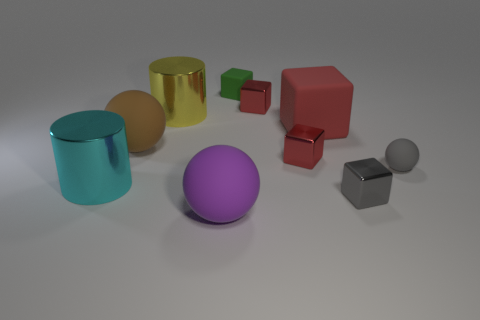Subtract all red cubes. How many were subtracted if there are1red cubes left? 2 Subtract all purple cylinders. How many red cubes are left? 3 Subtract all green cubes. How many cubes are left? 4 Subtract all gray shiny cubes. How many cubes are left? 4 Subtract all purple cubes. Subtract all purple cylinders. How many cubes are left? 5 Subtract all cylinders. How many objects are left? 8 Subtract 0 cyan blocks. How many objects are left? 10 Subtract all tiny brown rubber spheres. Subtract all big rubber spheres. How many objects are left? 8 Add 1 small gray blocks. How many small gray blocks are left? 2 Add 4 brown balls. How many brown balls exist? 5 